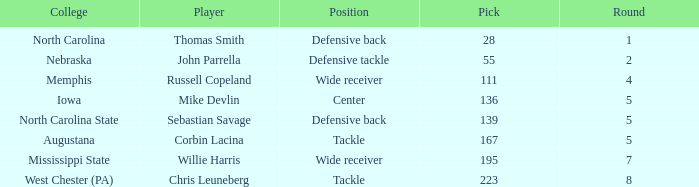What is the sum of Round with a Pick that is 55? 2.0. 